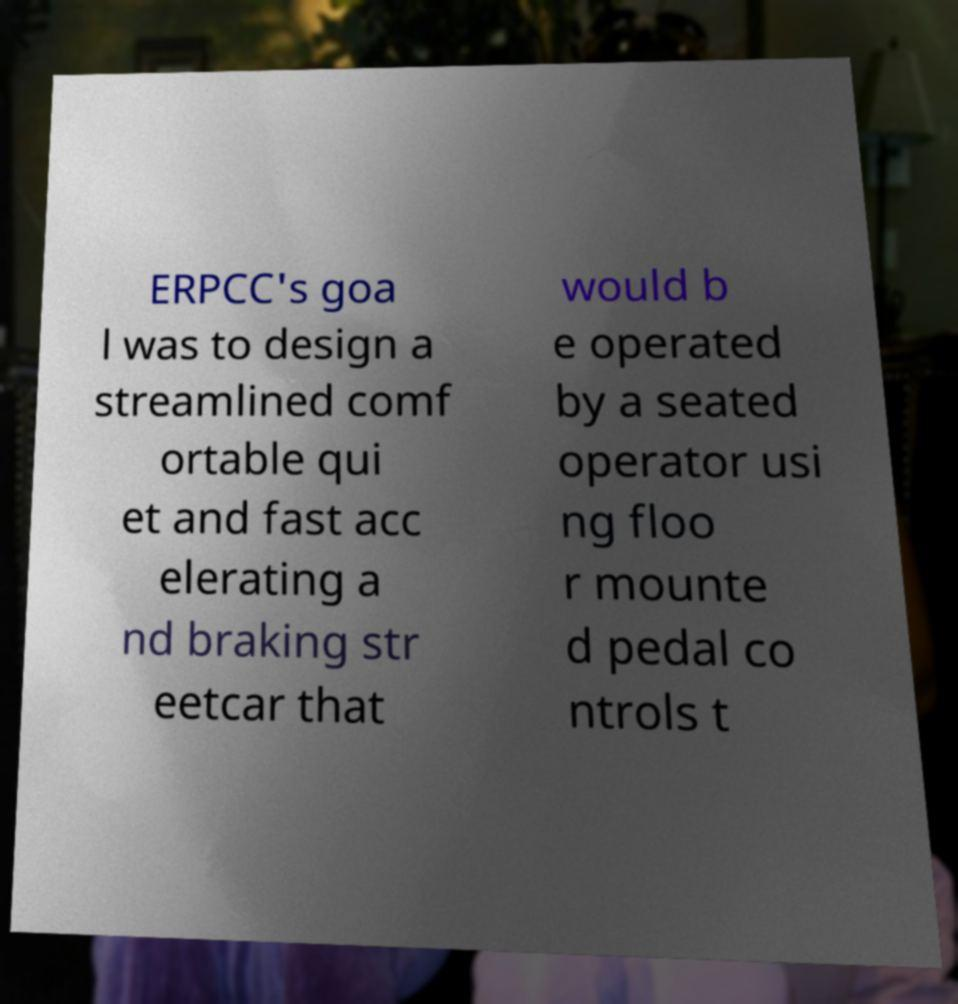Please identify and transcribe the text found in this image. ERPCC's goa l was to design a streamlined comf ortable qui et and fast acc elerating a nd braking str eetcar that would b e operated by a seated operator usi ng floo r mounte d pedal co ntrols t 